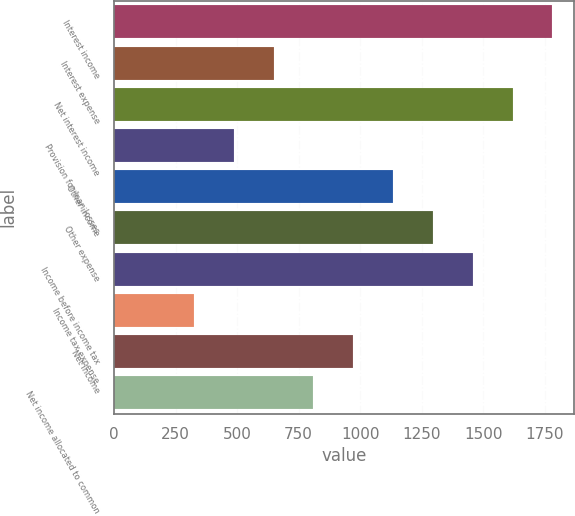Convert chart. <chart><loc_0><loc_0><loc_500><loc_500><bar_chart><fcel>Interest income<fcel>Interest expense<fcel>Net interest income<fcel>Provision for loan losses<fcel>Other income<fcel>Other expense<fcel>Income before income tax<fcel>Income tax expense<fcel>Net income<fcel>Net income allocated to common<nl><fcel>1781.88<fcel>648.55<fcel>1619.98<fcel>486.65<fcel>1134.27<fcel>1296.17<fcel>1458.08<fcel>324.75<fcel>972.36<fcel>810.45<nl></chart> 